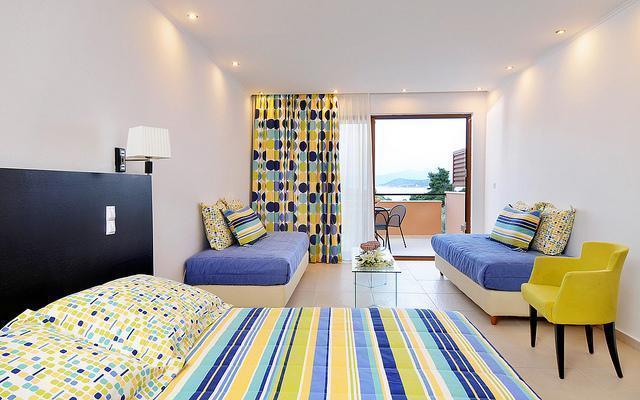How many couches can you see?
Give a very brief answer. 2. How many beds can you see?
Give a very brief answer. 3. 